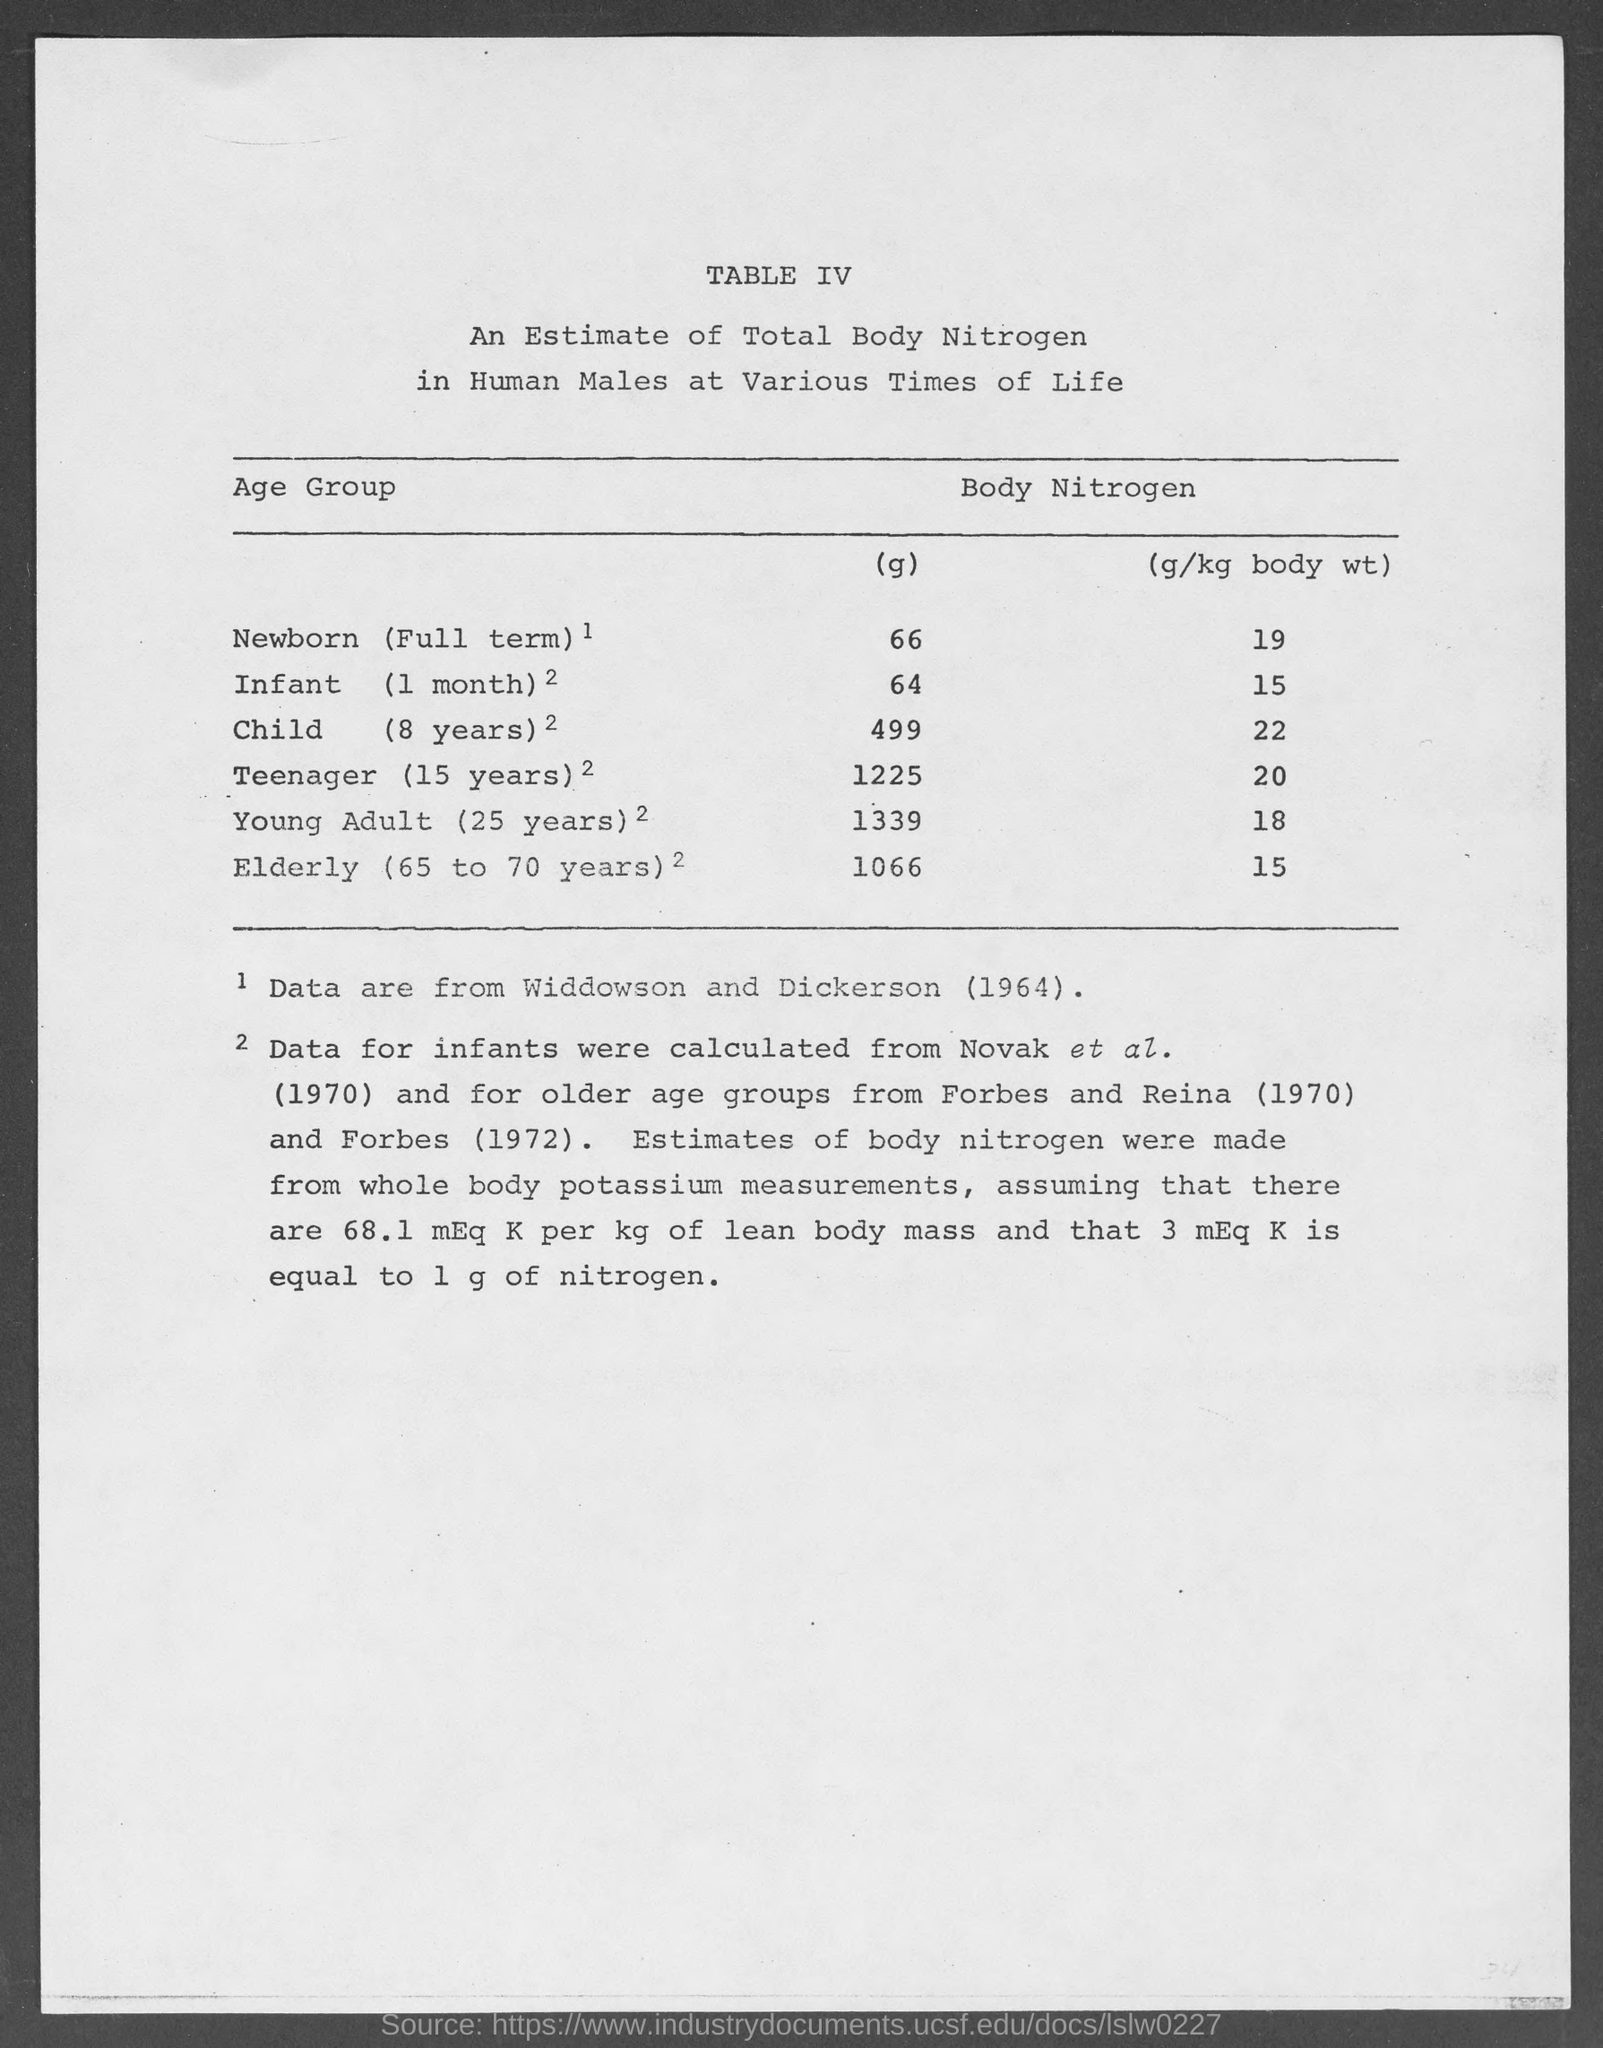What is the table no.?
Make the answer very short. IV. What is the amount of body nitrogen (g) in newborn ( full term) ?
Provide a short and direct response. 66. What is the amount of body nitrogen (g) in infant ( 1 month )?
Offer a very short reply. 64 g. What is the amount of body nitrogen (g) in child ( 8 years) ?
Provide a short and direct response. 499 g. What is the amount of body nitrogen (g) in teenager ( 15 years) ?
Your response must be concise. 1225 g. What is the amount of body nitrogen (g) in young adult ( 25 years)?
Give a very brief answer. 1339. What is the amount of body nitrogen (g) in elderly ( 65 to 70 years )?
Keep it short and to the point. 1066 g. What is the amount of body nitrogen (g/kg body wt) in newborn( full term)?
Give a very brief answer. 19. What is the amount of body nitrogen (g/kg body wt) in infant ( 1 month )?
Offer a terse response. 15. What is the amount of body nitrogen (g/kg body wt) in child ( 8 years)?
Offer a terse response. 22. 